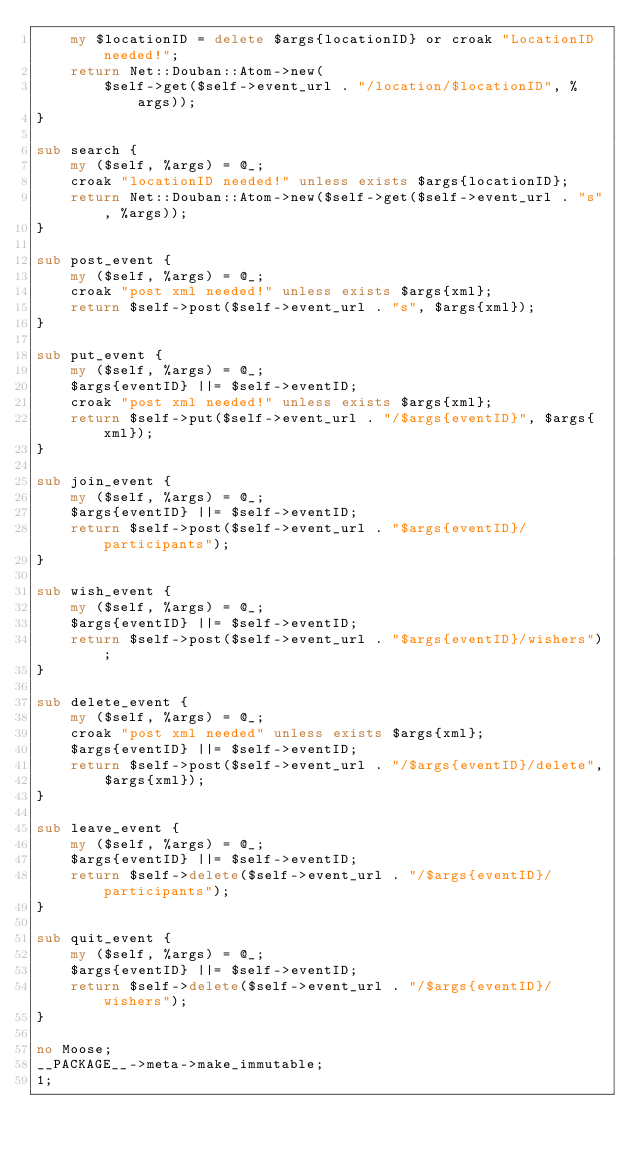Convert code to text. <code><loc_0><loc_0><loc_500><loc_500><_Perl_>    my $locationID = delete $args{locationID} or croak "LocationID needed!";
    return Net::Douban::Atom->new(
        $self->get($self->event_url . "/location/$locationID", %args));
}

sub search {
    my ($self, %args) = @_;
    croak "locationID needed!" unless exists $args{locationID};
    return Net::Douban::Atom->new($self->get($self->event_url . "s", %args));
}

sub post_event {
    my ($self, %args) = @_;
    croak "post xml needed!" unless exists $args{xml};
    return $self->post($self->event_url . "s", $args{xml});
}

sub put_event {
    my ($self, %args) = @_;
    $args{eventID} ||= $self->eventID;
    croak "post xml needed!" unless exists $args{xml};
    return $self->put($self->event_url . "/$args{eventID}", $args{xml});
}

sub join_event {
    my ($self, %args) = @_;
    $args{eventID} ||= $self->eventID;
    return $self->post($self->event_url . "$args{eventID}/participants");
}

sub wish_event {
    my ($self, %args) = @_;
    $args{eventID} ||= $self->eventID;
    return $self->post($self->event_url . "$args{eventID}/wishers");
}

sub delete_event {
    my ($self, %args) = @_;
    croak "post xml needed" unless exists $args{xml};
    $args{eventID} ||= $self->eventID;
    return $self->post($self->event_url . "/$args{eventID}/delete",
        $args{xml});
}

sub leave_event {
    my ($self, %args) = @_;
    $args{eventID} ||= $self->eventID;
    return $self->delete($self->event_url . "/$args{eventID}/participants");
}

sub quit_event {
    my ($self, %args) = @_;
    $args{eventID} ||= $self->eventID;
    return $self->delete($self->event_url . "/$args{eventID}/wishers");
}

no Moose;
__PACKAGE__->meta->make_immutable;
1;
</code> 